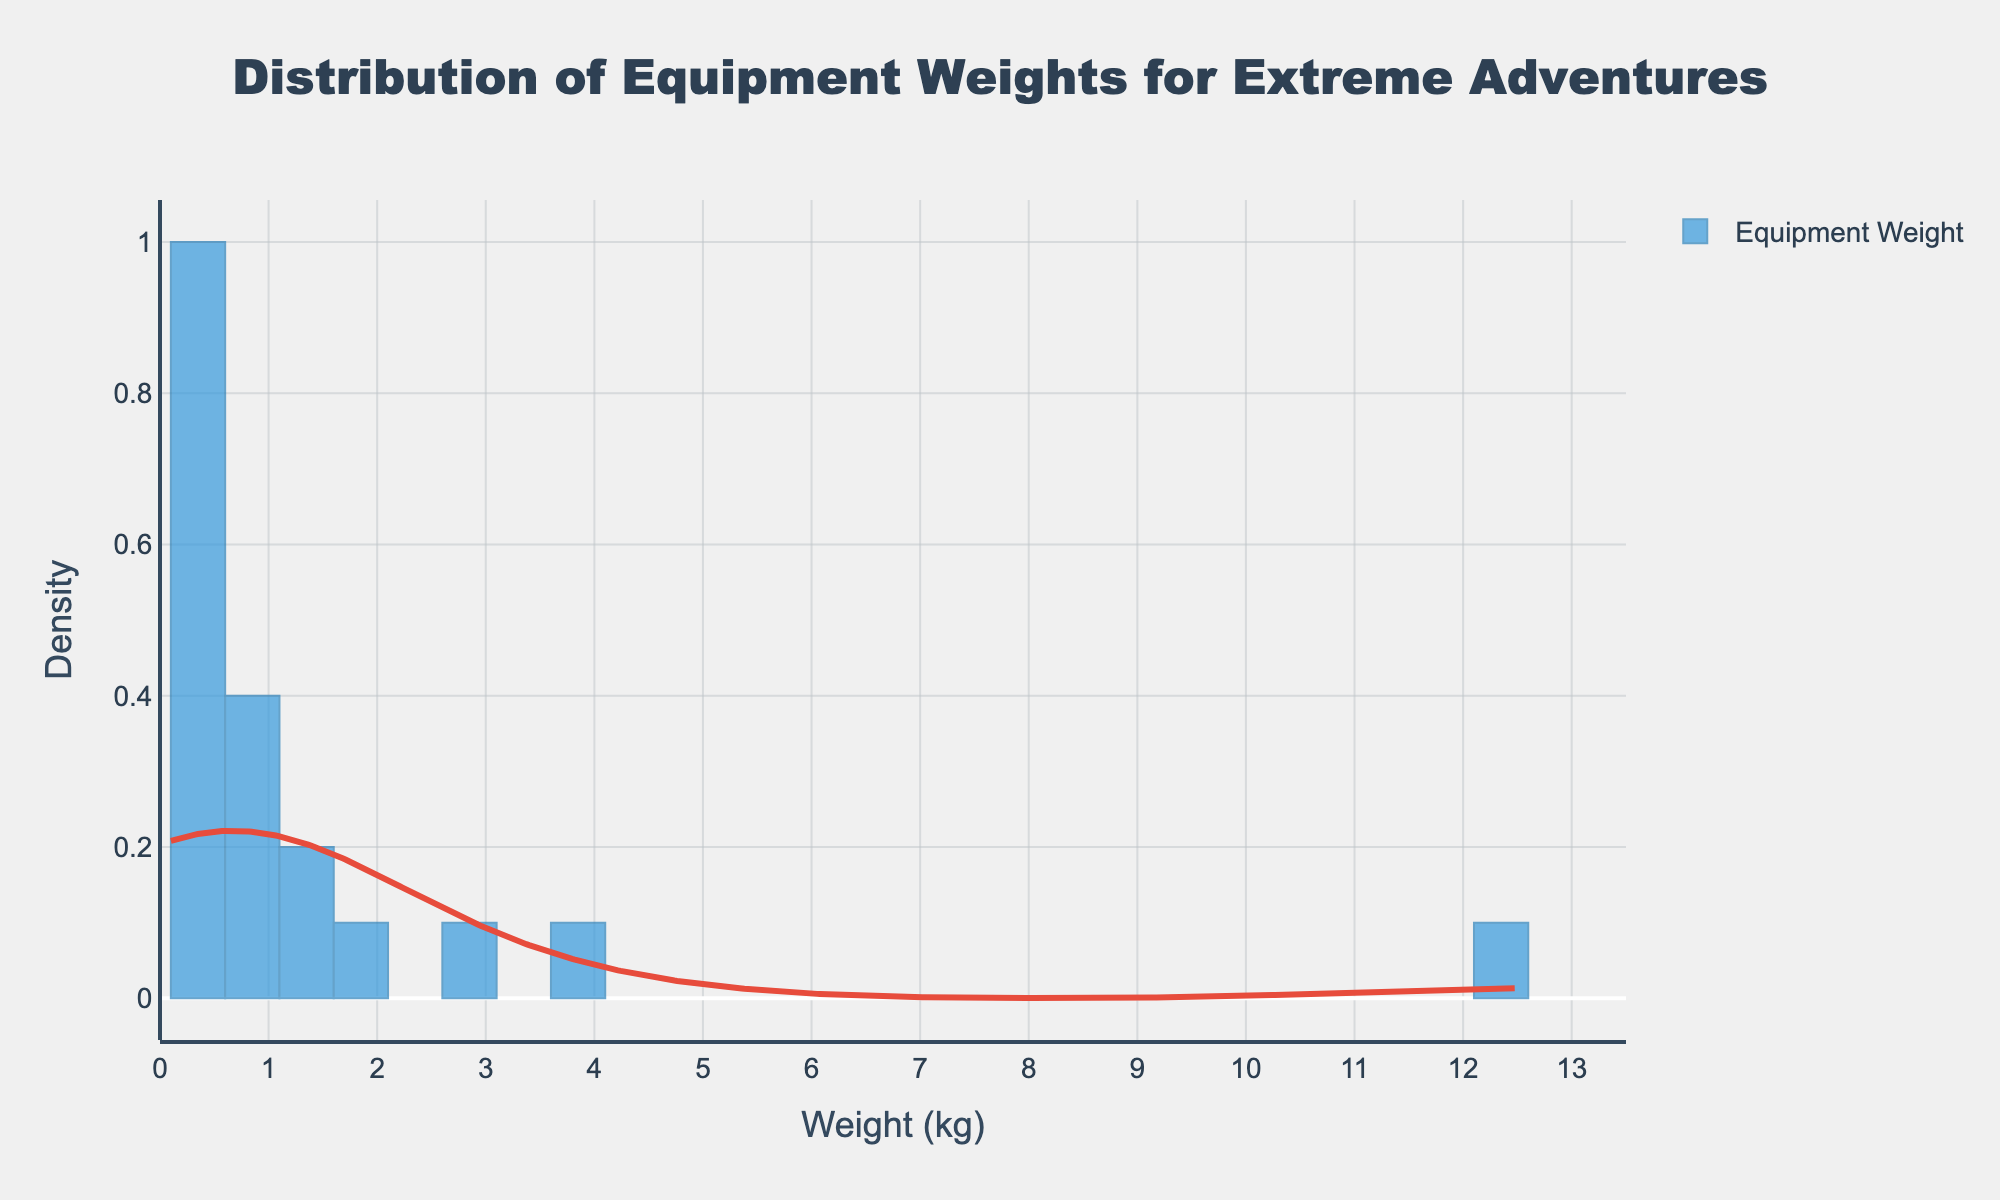What's the title of the figure? The title is displayed at the top of the figure and visually describes the purpose of the plot.
Answer: Distribution of Equipment Weights for Extreme Adventures What's the range of weights in the histogram? The x-axis represents the weight in kilograms, and its range extends from the minimum to the maximum weight represented.
Answer: 0 to 13.5 kg What is the most common weight range for equipment? The tallest bar in the histogram indicates the most common weight range.
Answer: 0-0.5 kg How many weight categories are depicted in the figure? The x-axis ticks indicate different weight categories. Counting the number of ticks gives the number of categories.
Answer: 15 Which equipment has a weight that lies in the highest density peak according to the KDE curve? The highest point on the KDE curve represents the weight category with the highest density. We check the equipment in this category.
Answer: GoPro, Headlamp, and GPS device (0.1-0.2 kg) How does the density of equipment weighting 3.7 kg compare to those weighing 1.6 kg? By looking at the height of the KDE curve at 3.7 kg and 1.6 kg, we can compare their densities.
Answer: 1.6 kg has a higher density than 3.7 kg Is the weight distribution skewed, and if so, in which direction? By observing the shape of the histogram and KDE curve, determine if they are skewed to the left or right.
Answer: Right-skewed What is the total weight of the lightest three equipment items? We identify the lightest three items: GoPro (0.2 kg), Headlamp (0.1 kg), and Multi-tool (0.3 kg), then sum their weights.
Answer: 0.6 kg Which piece of equipment falls into the least frequent weight category? The smallest bar or density curve trough indicates the least frequent weight category. We check which equipment lies in that category.
Answer: Water filtration system (0.4 kg) What is the approximate density for equipment weighing 2.8 kg? Look at the KDE curve height at 2.8 kg to estimate the density value.
Answer: Around 0.04 